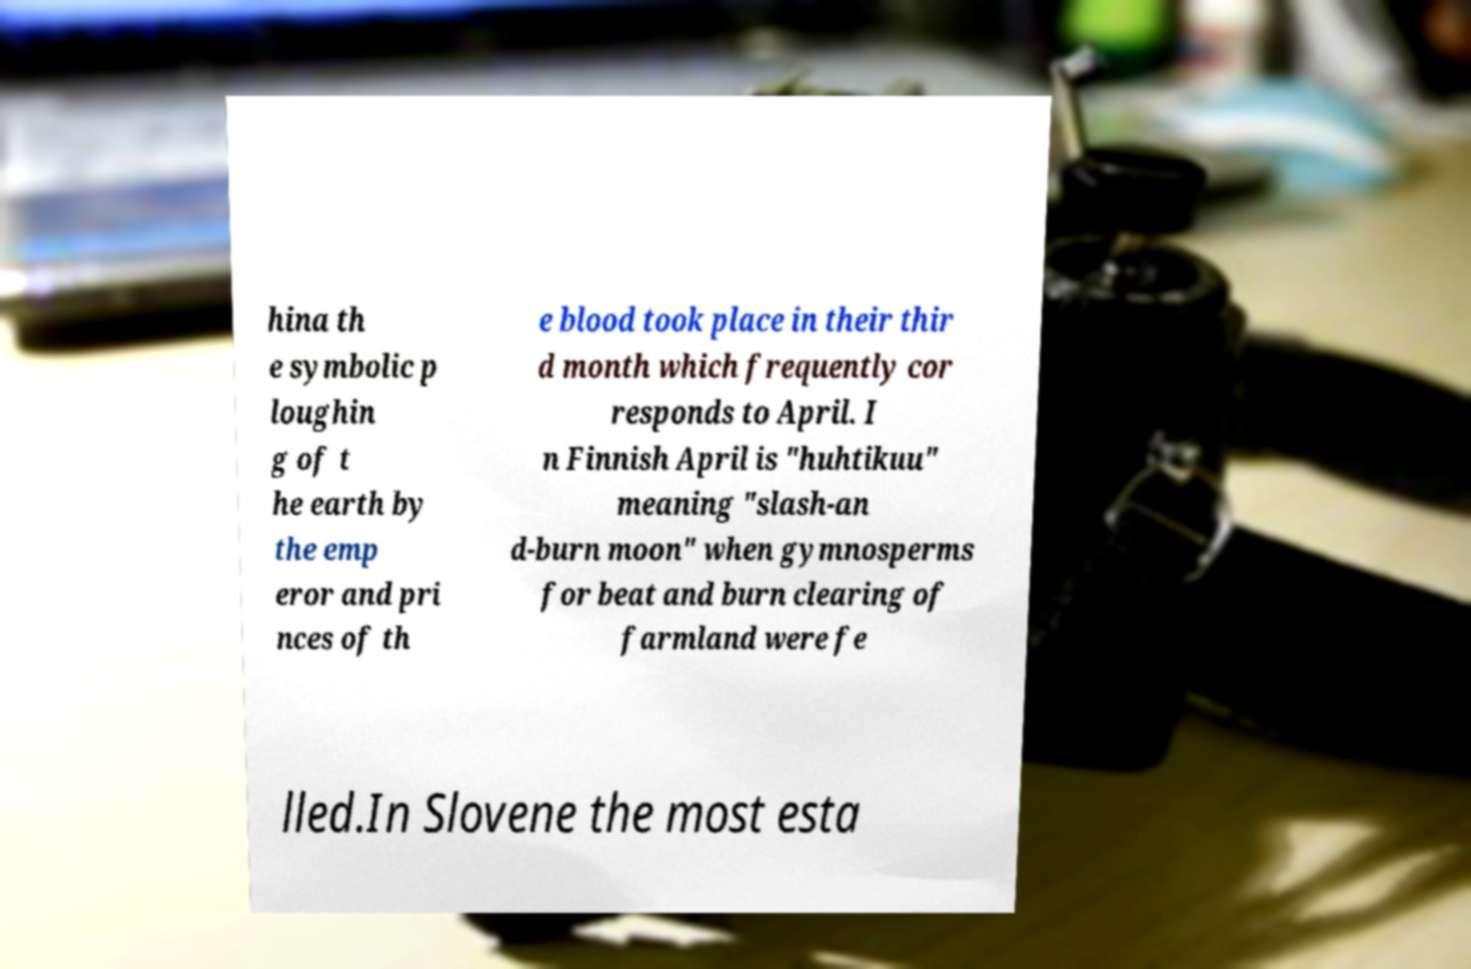There's text embedded in this image that I need extracted. Can you transcribe it verbatim? hina th e symbolic p loughin g of t he earth by the emp eror and pri nces of th e blood took place in their thir d month which frequently cor responds to April. I n Finnish April is "huhtikuu" meaning "slash-an d-burn moon" when gymnosperms for beat and burn clearing of farmland were fe lled.In Slovene the most esta 